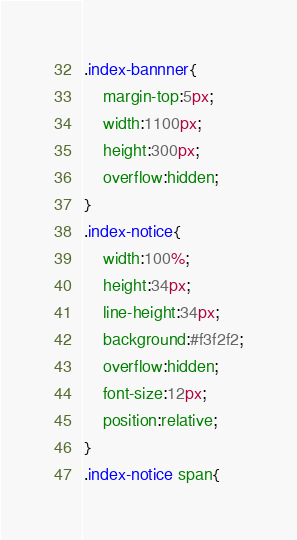<code> <loc_0><loc_0><loc_500><loc_500><_CSS_>.index-bannner{
	margin-top:5px;
	width:1100px;
	height:300px;
	overflow:hidden;
}
.index-notice{
	width:100%;
	height:34px;
	line-height:34px;
	background:#f3f2f2;
	overflow:hidden;
	font-size:12px;
	position:relative;
}
.index-notice span{</code> 